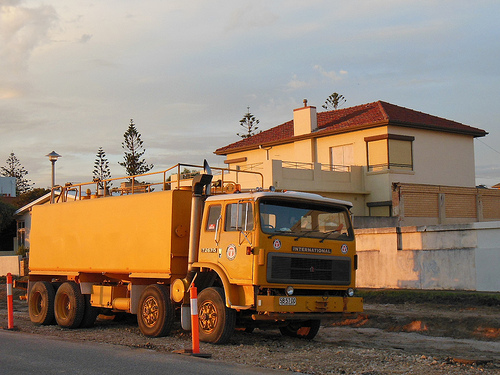Please provide a description for the region specified [0.04, 0.67, 0.47, 0.8]. The region contains four sturdy tires with vibrant yellow rims, possibly indicative of heavy-duty usage or special operational requirements. 